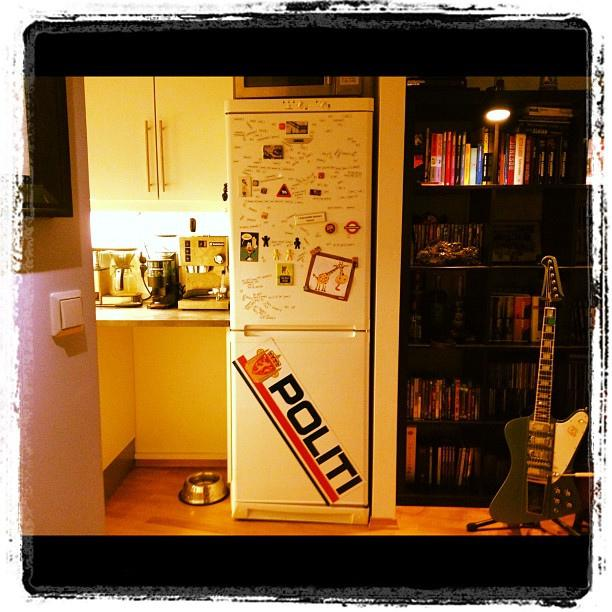In what nation is this apartment likely to be situated?

Choices:
A) england
B) denmark
C) france
D) canada denmark 